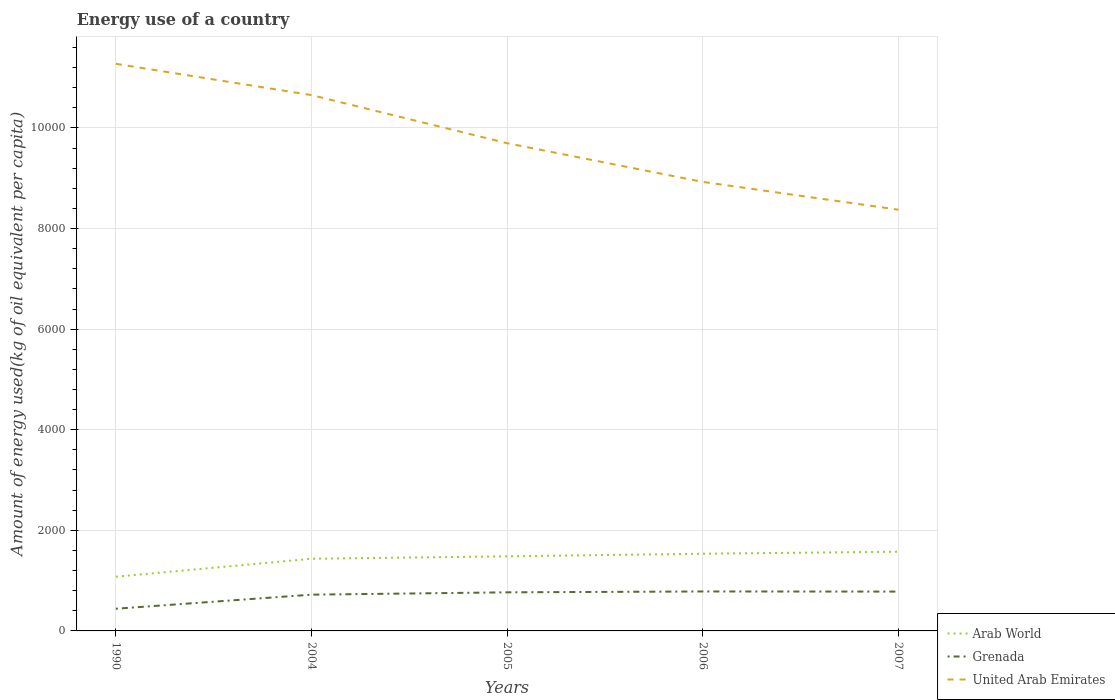Is the number of lines equal to the number of legend labels?
Provide a short and direct response. Yes. Across all years, what is the maximum amount of energy used in in Arab World?
Your response must be concise. 1077.86. In which year was the amount of energy used in in Grenada maximum?
Give a very brief answer. 1990. What is the total amount of energy used in in Arab World in the graph?
Make the answer very short. -40.17. What is the difference between the highest and the second highest amount of energy used in in United Arab Emirates?
Give a very brief answer. 2900.49. What is the difference between the highest and the lowest amount of energy used in in Arab World?
Provide a short and direct response. 4. Is the amount of energy used in in Grenada strictly greater than the amount of energy used in in Arab World over the years?
Offer a terse response. Yes. How many lines are there?
Give a very brief answer. 3. Does the graph contain any zero values?
Keep it short and to the point. No. How many legend labels are there?
Offer a very short reply. 3. What is the title of the graph?
Keep it short and to the point. Energy use of a country. What is the label or title of the X-axis?
Your response must be concise. Years. What is the label or title of the Y-axis?
Provide a succinct answer. Amount of energy used(kg of oil equivalent per capita). What is the Amount of energy used(kg of oil equivalent per capita) in Arab World in 1990?
Ensure brevity in your answer.  1077.86. What is the Amount of energy used(kg of oil equivalent per capita) in Grenada in 1990?
Provide a short and direct response. 441.13. What is the Amount of energy used(kg of oil equivalent per capita) of United Arab Emirates in 1990?
Keep it short and to the point. 1.13e+04. What is the Amount of energy used(kg of oil equivalent per capita) of Arab World in 2004?
Offer a terse response. 1434.84. What is the Amount of energy used(kg of oil equivalent per capita) in Grenada in 2004?
Your answer should be very brief. 720.85. What is the Amount of energy used(kg of oil equivalent per capita) in United Arab Emirates in 2004?
Offer a terse response. 1.07e+04. What is the Amount of energy used(kg of oil equivalent per capita) of Arab World in 2005?
Make the answer very short. 1482.94. What is the Amount of energy used(kg of oil equivalent per capita) of Grenada in 2005?
Make the answer very short. 767.36. What is the Amount of energy used(kg of oil equivalent per capita) in United Arab Emirates in 2005?
Keep it short and to the point. 9696.48. What is the Amount of energy used(kg of oil equivalent per capita) of Arab World in 2006?
Provide a short and direct response. 1534.62. What is the Amount of energy used(kg of oil equivalent per capita) of Grenada in 2006?
Ensure brevity in your answer.  784.44. What is the Amount of energy used(kg of oil equivalent per capita) of United Arab Emirates in 2006?
Offer a very short reply. 8926.97. What is the Amount of energy used(kg of oil equivalent per capita) of Arab World in 2007?
Keep it short and to the point. 1574.79. What is the Amount of energy used(kg of oil equivalent per capita) of Grenada in 2007?
Give a very brief answer. 781.95. What is the Amount of energy used(kg of oil equivalent per capita) of United Arab Emirates in 2007?
Offer a very short reply. 8374.44. Across all years, what is the maximum Amount of energy used(kg of oil equivalent per capita) in Arab World?
Make the answer very short. 1574.79. Across all years, what is the maximum Amount of energy used(kg of oil equivalent per capita) of Grenada?
Offer a very short reply. 784.44. Across all years, what is the maximum Amount of energy used(kg of oil equivalent per capita) in United Arab Emirates?
Offer a very short reply. 1.13e+04. Across all years, what is the minimum Amount of energy used(kg of oil equivalent per capita) in Arab World?
Give a very brief answer. 1077.86. Across all years, what is the minimum Amount of energy used(kg of oil equivalent per capita) of Grenada?
Give a very brief answer. 441.13. Across all years, what is the minimum Amount of energy used(kg of oil equivalent per capita) of United Arab Emirates?
Ensure brevity in your answer.  8374.44. What is the total Amount of energy used(kg of oil equivalent per capita) in Arab World in the graph?
Keep it short and to the point. 7105.06. What is the total Amount of energy used(kg of oil equivalent per capita) in Grenada in the graph?
Your answer should be compact. 3495.72. What is the total Amount of energy used(kg of oil equivalent per capita) in United Arab Emirates in the graph?
Give a very brief answer. 4.89e+04. What is the difference between the Amount of energy used(kg of oil equivalent per capita) of Arab World in 1990 and that in 2004?
Provide a succinct answer. -356.98. What is the difference between the Amount of energy used(kg of oil equivalent per capita) in Grenada in 1990 and that in 2004?
Your answer should be compact. -279.72. What is the difference between the Amount of energy used(kg of oil equivalent per capita) of United Arab Emirates in 1990 and that in 2004?
Offer a very short reply. 621.99. What is the difference between the Amount of energy used(kg of oil equivalent per capita) of Arab World in 1990 and that in 2005?
Offer a terse response. -405.08. What is the difference between the Amount of energy used(kg of oil equivalent per capita) in Grenada in 1990 and that in 2005?
Your answer should be very brief. -326.23. What is the difference between the Amount of energy used(kg of oil equivalent per capita) in United Arab Emirates in 1990 and that in 2005?
Your answer should be very brief. 1578.45. What is the difference between the Amount of energy used(kg of oil equivalent per capita) in Arab World in 1990 and that in 2006?
Ensure brevity in your answer.  -456.76. What is the difference between the Amount of energy used(kg of oil equivalent per capita) of Grenada in 1990 and that in 2006?
Give a very brief answer. -343.31. What is the difference between the Amount of energy used(kg of oil equivalent per capita) of United Arab Emirates in 1990 and that in 2006?
Your answer should be very brief. 2347.96. What is the difference between the Amount of energy used(kg of oil equivalent per capita) in Arab World in 1990 and that in 2007?
Your response must be concise. -496.93. What is the difference between the Amount of energy used(kg of oil equivalent per capita) of Grenada in 1990 and that in 2007?
Keep it short and to the point. -340.82. What is the difference between the Amount of energy used(kg of oil equivalent per capita) in United Arab Emirates in 1990 and that in 2007?
Ensure brevity in your answer.  2900.49. What is the difference between the Amount of energy used(kg of oil equivalent per capita) of Arab World in 2004 and that in 2005?
Offer a very short reply. -48.1. What is the difference between the Amount of energy used(kg of oil equivalent per capita) of Grenada in 2004 and that in 2005?
Your answer should be very brief. -46.51. What is the difference between the Amount of energy used(kg of oil equivalent per capita) in United Arab Emirates in 2004 and that in 2005?
Offer a terse response. 956.46. What is the difference between the Amount of energy used(kg of oil equivalent per capita) in Arab World in 2004 and that in 2006?
Ensure brevity in your answer.  -99.78. What is the difference between the Amount of energy used(kg of oil equivalent per capita) in Grenada in 2004 and that in 2006?
Give a very brief answer. -63.59. What is the difference between the Amount of energy used(kg of oil equivalent per capita) in United Arab Emirates in 2004 and that in 2006?
Give a very brief answer. 1725.97. What is the difference between the Amount of energy used(kg of oil equivalent per capita) of Arab World in 2004 and that in 2007?
Keep it short and to the point. -139.95. What is the difference between the Amount of energy used(kg of oil equivalent per capita) of Grenada in 2004 and that in 2007?
Your response must be concise. -61.1. What is the difference between the Amount of energy used(kg of oil equivalent per capita) in United Arab Emirates in 2004 and that in 2007?
Keep it short and to the point. 2278.5. What is the difference between the Amount of energy used(kg of oil equivalent per capita) in Arab World in 2005 and that in 2006?
Offer a very short reply. -51.68. What is the difference between the Amount of energy used(kg of oil equivalent per capita) in Grenada in 2005 and that in 2006?
Your answer should be compact. -17.08. What is the difference between the Amount of energy used(kg of oil equivalent per capita) of United Arab Emirates in 2005 and that in 2006?
Your answer should be very brief. 769.51. What is the difference between the Amount of energy used(kg of oil equivalent per capita) of Arab World in 2005 and that in 2007?
Keep it short and to the point. -91.85. What is the difference between the Amount of energy used(kg of oil equivalent per capita) of Grenada in 2005 and that in 2007?
Make the answer very short. -14.6. What is the difference between the Amount of energy used(kg of oil equivalent per capita) in United Arab Emirates in 2005 and that in 2007?
Keep it short and to the point. 1322.04. What is the difference between the Amount of energy used(kg of oil equivalent per capita) in Arab World in 2006 and that in 2007?
Make the answer very short. -40.17. What is the difference between the Amount of energy used(kg of oil equivalent per capita) of Grenada in 2006 and that in 2007?
Give a very brief answer. 2.48. What is the difference between the Amount of energy used(kg of oil equivalent per capita) of United Arab Emirates in 2006 and that in 2007?
Offer a very short reply. 552.53. What is the difference between the Amount of energy used(kg of oil equivalent per capita) in Arab World in 1990 and the Amount of energy used(kg of oil equivalent per capita) in Grenada in 2004?
Offer a very short reply. 357.01. What is the difference between the Amount of energy used(kg of oil equivalent per capita) in Arab World in 1990 and the Amount of energy used(kg of oil equivalent per capita) in United Arab Emirates in 2004?
Your answer should be compact. -9575.08. What is the difference between the Amount of energy used(kg of oil equivalent per capita) of Grenada in 1990 and the Amount of energy used(kg of oil equivalent per capita) of United Arab Emirates in 2004?
Your answer should be very brief. -1.02e+04. What is the difference between the Amount of energy used(kg of oil equivalent per capita) in Arab World in 1990 and the Amount of energy used(kg of oil equivalent per capita) in Grenada in 2005?
Provide a succinct answer. 310.5. What is the difference between the Amount of energy used(kg of oil equivalent per capita) of Arab World in 1990 and the Amount of energy used(kg of oil equivalent per capita) of United Arab Emirates in 2005?
Give a very brief answer. -8618.62. What is the difference between the Amount of energy used(kg of oil equivalent per capita) of Grenada in 1990 and the Amount of energy used(kg of oil equivalent per capita) of United Arab Emirates in 2005?
Ensure brevity in your answer.  -9255.36. What is the difference between the Amount of energy used(kg of oil equivalent per capita) of Arab World in 1990 and the Amount of energy used(kg of oil equivalent per capita) of Grenada in 2006?
Ensure brevity in your answer.  293.42. What is the difference between the Amount of energy used(kg of oil equivalent per capita) of Arab World in 1990 and the Amount of energy used(kg of oil equivalent per capita) of United Arab Emirates in 2006?
Keep it short and to the point. -7849.11. What is the difference between the Amount of energy used(kg of oil equivalent per capita) in Grenada in 1990 and the Amount of energy used(kg of oil equivalent per capita) in United Arab Emirates in 2006?
Your response must be concise. -8485.85. What is the difference between the Amount of energy used(kg of oil equivalent per capita) in Arab World in 1990 and the Amount of energy used(kg of oil equivalent per capita) in Grenada in 2007?
Make the answer very short. 295.91. What is the difference between the Amount of energy used(kg of oil equivalent per capita) in Arab World in 1990 and the Amount of energy used(kg of oil equivalent per capita) in United Arab Emirates in 2007?
Offer a terse response. -7296.58. What is the difference between the Amount of energy used(kg of oil equivalent per capita) of Grenada in 1990 and the Amount of energy used(kg of oil equivalent per capita) of United Arab Emirates in 2007?
Make the answer very short. -7933.32. What is the difference between the Amount of energy used(kg of oil equivalent per capita) of Arab World in 2004 and the Amount of energy used(kg of oil equivalent per capita) of Grenada in 2005?
Make the answer very short. 667.49. What is the difference between the Amount of energy used(kg of oil equivalent per capita) in Arab World in 2004 and the Amount of energy used(kg of oil equivalent per capita) in United Arab Emirates in 2005?
Ensure brevity in your answer.  -8261.64. What is the difference between the Amount of energy used(kg of oil equivalent per capita) of Grenada in 2004 and the Amount of energy used(kg of oil equivalent per capita) of United Arab Emirates in 2005?
Ensure brevity in your answer.  -8975.64. What is the difference between the Amount of energy used(kg of oil equivalent per capita) of Arab World in 2004 and the Amount of energy used(kg of oil equivalent per capita) of Grenada in 2006?
Your answer should be compact. 650.41. What is the difference between the Amount of energy used(kg of oil equivalent per capita) in Arab World in 2004 and the Amount of energy used(kg of oil equivalent per capita) in United Arab Emirates in 2006?
Provide a succinct answer. -7492.13. What is the difference between the Amount of energy used(kg of oil equivalent per capita) of Grenada in 2004 and the Amount of energy used(kg of oil equivalent per capita) of United Arab Emirates in 2006?
Make the answer very short. -8206.13. What is the difference between the Amount of energy used(kg of oil equivalent per capita) of Arab World in 2004 and the Amount of energy used(kg of oil equivalent per capita) of Grenada in 2007?
Offer a terse response. 652.89. What is the difference between the Amount of energy used(kg of oil equivalent per capita) in Arab World in 2004 and the Amount of energy used(kg of oil equivalent per capita) in United Arab Emirates in 2007?
Offer a very short reply. -6939.6. What is the difference between the Amount of energy used(kg of oil equivalent per capita) of Grenada in 2004 and the Amount of energy used(kg of oil equivalent per capita) of United Arab Emirates in 2007?
Your answer should be very brief. -7653.6. What is the difference between the Amount of energy used(kg of oil equivalent per capita) of Arab World in 2005 and the Amount of energy used(kg of oil equivalent per capita) of Grenada in 2006?
Make the answer very short. 698.51. What is the difference between the Amount of energy used(kg of oil equivalent per capita) of Arab World in 2005 and the Amount of energy used(kg of oil equivalent per capita) of United Arab Emirates in 2006?
Make the answer very short. -7444.03. What is the difference between the Amount of energy used(kg of oil equivalent per capita) in Grenada in 2005 and the Amount of energy used(kg of oil equivalent per capita) in United Arab Emirates in 2006?
Ensure brevity in your answer.  -8159.62. What is the difference between the Amount of energy used(kg of oil equivalent per capita) in Arab World in 2005 and the Amount of energy used(kg of oil equivalent per capita) in Grenada in 2007?
Provide a succinct answer. 700.99. What is the difference between the Amount of energy used(kg of oil equivalent per capita) of Arab World in 2005 and the Amount of energy used(kg of oil equivalent per capita) of United Arab Emirates in 2007?
Your response must be concise. -6891.5. What is the difference between the Amount of energy used(kg of oil equivalent per capita) in Grenada in 2005 and the Amount of energy used(kg of oil equivalent per capita) in United Arab Emirates in 2007?
Make the answer very short. -7607.09. What is the difference between the Amount of energy used(kg of oil equivalent per capita) of Arab World in 2006 and the Amount of energy used(kg of oil equivalent per capita) of Grenada in 2007?
Your answer should be very brief. 752.67. What is the difference between the Amount of energy used(kg of oil equivalent per capita) of Arab World in 2006 and the Amount of energy used(kg of oil equivalent per capita) of United Arab Emirates in 2007?
Offer a terse response. -6839.82. What is the difference between the Amount of energy used(kg of oil equivalent per capita) of Grenada in 2006 and the Amount of energy used(kg of oil equivalent per capita) of United Arab Emirates in 2007?
Make the answer very short. -7590.01. What is the average Amount of energy used(kg of oil equivalent per capita) in Arab World per year?
Provide a succinct answer. 1421.01. What is the average Amount of energy used(kg of oil equivalent per capita) of Grenada per year?
Ensure brevity in your answer.  699.14. What is the average Amount of energy used(kg of oil equivalent per capita) in United Arab Emirates per year?
Provide a short and direct response. 9785.16. In the year 1990, what is the difference between the Amount of energy used(kg of oil equivalent per capita) of Arab World and Amount of energy used(kg of oil equivalent per capita) of Grenada?
Provide a short and direct response. 636.73. In the year 1990, what is the difference between the Amount of energy used(kg of oil equivalent per capita) in Arab World and Amount of energy used(kg of oil equivalent per capita) in United Arab Emirates?
Ensure brevity in your answer.  -1.02e+04. In the year 1990, what is the difference between the Amount of energy used(kg of oil equivalent per capita) of Grenada and Amount of energy used(kg of oil equivalent per capita) of United Arab Emirates?
Provide a succinct answer. -1.08e+04. In the year 2004, what is the difference between the Amount of energy used(kg of oil equivalent per capita) in Arab World and Amount of energy used(kg of oil equivalent per capita) in Grenada?
Keep it short and to the point. 713.99. In the year 2004, what is the difference between the Amount of energy used(kg of oil equivalent per capita) in Arab World and Amount of energy used(kg of oil equivalent per capita) in United Arab Emirates?
Provide a short and direct response. -9218.1. In the year 2004, what is the difference between the Amount of energy used(kg of oil equivalent per capita) in Grenada and Amount of energy used(kg of oil equivalent per capita) in United Arab Emirates?
Your response must be concise. -9932.1. In the year 2005, what is the difference between the Amount of energy used(kg of oil equivalent per capita) in Arab World and Amount of energy used(kg of oil equivalent per capita) in Grenada?
Provide a short and direct response. 715.59. In the year 2005, what is the difference between the Amount of energy used(kg of oil equivalent per capita) in Arab World and Amount of energy used(kg of oil equivalent per capita) in United Arab Emirates?
Your response must be concise. -8213.54. In the year 2005, what is the difference between the Amount of energy used(kg of oil equivalent per capita) in Grenada and Amount of energy used(kg of oil equivalent per capita) in United Arab Emirates?
Provide a short and direct response. -8929.13. In the year 2006, what is the difference between the Amount of energy used(kg of oil equivalent per capita) in Arab World and Amount of energy used(kg of oil equivalent per capita) in Grenada?
Provide a short and direct response. 750.19. In the year 2006, what is the difference between the Amount of energy used(kg of oil equivalent per capita) in Arab World and Amount of energy used(kg of oil equivalent per capita) in United Arab Emirates?
Make the answer very short. -7392.35. In the year 2006, what is the difference between the Amount of energy used(kg of oil equivalent per capita) of Grenada and Amount of energy used(kg of oil equivalent per capita) of United Arab Emirates?
Provide a short and direct response. -8142.54. In the year 2007, what is the difference between the Amount of energy used(kg of oil equivalent per capita) in Arab World and Amount of energy used(kg of oil equivalent per capita) in Grenada?
Make the answer very short. 792.84. In the year 2007, what is the difference between the Amount of energy used(kg of oil equivalent per capita) in Arab World and Amount of energy used(kg of oil equivalent per capita) in United Arab Emirates?
Offer a terse response. -6799.65. In the year 2007, what is the difference between the Amount of energy used(kg of oil equivalent per capita) of Grenada and Amount of energy used(kg of oil equivalent per capita) of United Arab Emirates?
Keep it short and to the point. -7592.49. What is the ratio of the Amount of energy used(kg of oil equivalent per capita) in Arab World in 1990 to that in 2004?
Your answer should be compact. 0.75. What is the ratio of the Amount of energy used(kg of oil equivalent per capita) of Grenada in 1990 to that in 2004?
Keep it short and to the point. 0.61. What is the ratio of the Amount of energy used(kg of oil equivalent per capita) in United Arab Emirates in 1990 to that in 2004?
Provide a succinct answer. 1.06. What is the ratio of the Amount of energy used(kg of oil equivalent per capita) in Arab World in 1990 to that in 2005?
Your answer should be compact. 0.73. What is the ratio of the Amount of energy used(kg of oil equivalent per capita) of Grenada in 1990 to that in 2005?
Your answer should be compact. 0.57. What is the ratio of the Amount of energy used(kg of oil equivalent per capita) in United Arab Emirates in 1990 to that in 2005?
Your response must be concise. 1.16. What is the ratio of the Amount of energy used(kg of oil equivalent per capita) in Arab World in 1990 to that in 2006?
Provide a succinct answer. 0.7. What is the ratio of the Amount of energy used(kg of oil equivalent per capita) of Grenada in 1990 to that in 2006?
Ensure brevity in your answer.  0.56. What is the ratio of the Amount of energy used(kg of oil equivalent per capita) of United Arab Emirates in 1990 to that in 2006?
Provide a succinct answer. 1.26. What is the ratio of the Amount of energy used(kg of oil equivalent per capita) in Arab World in 1990 to that in 2007?
Provide a succinct answer. 0.68. What is the ratio of the Amount of energy used(kg of oil equivalent per capita) of Grenada in 1990 to that in 2007?
Give a very brief answer. 0.56. What is the ratio of the Amount of energy used(kg of oil equivalent per capita) of United Arab Emirates in 1990 to that in 2007?
Offer a terse response. 1.35. What is the ratio of the Amount of energy used(kg of oil equivalent per capita) in Arab World in 2004 to that in 2005?
Your answer should be compact. 0.97. What is the ratio of the Amount of energy used(kg of oil equivalent per capita) of Grenada in 2004 to that in 2005?
Offer a very short reply. 0.94. What is the ratio of the Amount of energy used(kg of oil equivalent per capita) in United Arab Emirates in 2004 to that in 2005?
Give a very brief answer. 1.1. What is the ratio of the Amount of energy used(kg of oil equivalent per capita) of Arab World in 2004 to that in 2006?
Ensure brevity in your answer.  0.94. What is the ratio of the Amount of energy used(kg of oil equivalent per capita) of Grenada in 2004 to that in 2006?
Keep it short and to the point. 0.92. What is the ratio of the Amount of energy used(kg of oil equivalent per capita) in United Arab Emirates in 2004 to that in 2006?
Make the answer very short. 1.19. What is the ratio of the Amount of energy used(kg of oil equivalent per capita) in Arab World in 2004 to that in 2007?
Keep it short and to the point. 0.91. What is the ratio of the Amount of energy used(kg of oil equivalent per capita) in Grenada in 2004 to that in 2007?
Give a very brief answer. 0.92. What is the ratio of the Amount of energy used(kg of oil equivalent per capita) in United Arab Emirates in 2004 to that in 2007?
Keep it short and to the point. 1.27. What is the ratio of the Amount of energy used(kg of oil equivalent per capita) of Arab World in 2005 to that in 2006?
Ensure brevity in your answer.  0.97. What is the ratio of the Amount of energy used(kg of oil equivalent per capita) of Grenada in 2005 to that in 2006?
Your response must be concise. 0.98. What is the ratio of the Amount of energy used(kg of oil equivalent per capita) in United Arab Emirates in 2005 to that in 2006?
Your response must be concise. 1.09. What is the ratio of the Amount of energy used(kg of oil equivalent per capita) of Arab World in 2005 to that in 2007?
Keep it short and to the point. 0.94. What is the ratio of the Amount of energy used(kg of oil equivalent per capita) in Grenada in 2005 to that in 2007?
Keep it short and to the point. 0.98. What is the ratio of the Amount of energy used(kg of oil equivalent per capita) in United Arab Emirates in 2005 to that in 2007?
Offer a terse response. 1.16. What is the ratio of the Amount of energy used(kg of oil equivalent per capita) of Arab World in 2006 to that in 2007?
Keep it short and to the point. 0.97. What is the ratio of the Amount of energy used(kg of oil equivalent per capita) in Grenada in 2006 to that in 2007?
Give a very brief answer. 1. What is the ratio of the Amount of energy used(kg of oil equivalent per capita) of United Arab Emirates in 2006 to that in 2007?
Offer a terse response. 1.07. What is the difference between the highest and the second highest Amount of energy used(kg of oil equivalent per capita) of Arab World?
Give a very brief answer. 40.17. What is the difference between the highest and the second highest Amount of energy used(kg of oil equivalent per capita) of Grenada?
Offer a very short reply. 2.48. What is the difference between the highest and the second highest Amount of energy used(kg of oil equivalent per capita) of United Arab Emirates?
Provide a short and direct response. 621.99. What is the difference between the highest and the lowest Amount of energy used(kg of oil equivalent per capita) in Arab World?
Provide a short and direct response. 496.93. What is the difference between the highest and the lowest Amount of energy used(kg of oil equivalent per capita) of Grenada?
Provide a short and direct response. 343.31. What is the difference between the highest and the lowest Amount of energy used(kg of oil equivalent per capita) in United Arab Emirates?
Keep it short and to the point. 2900.49. 